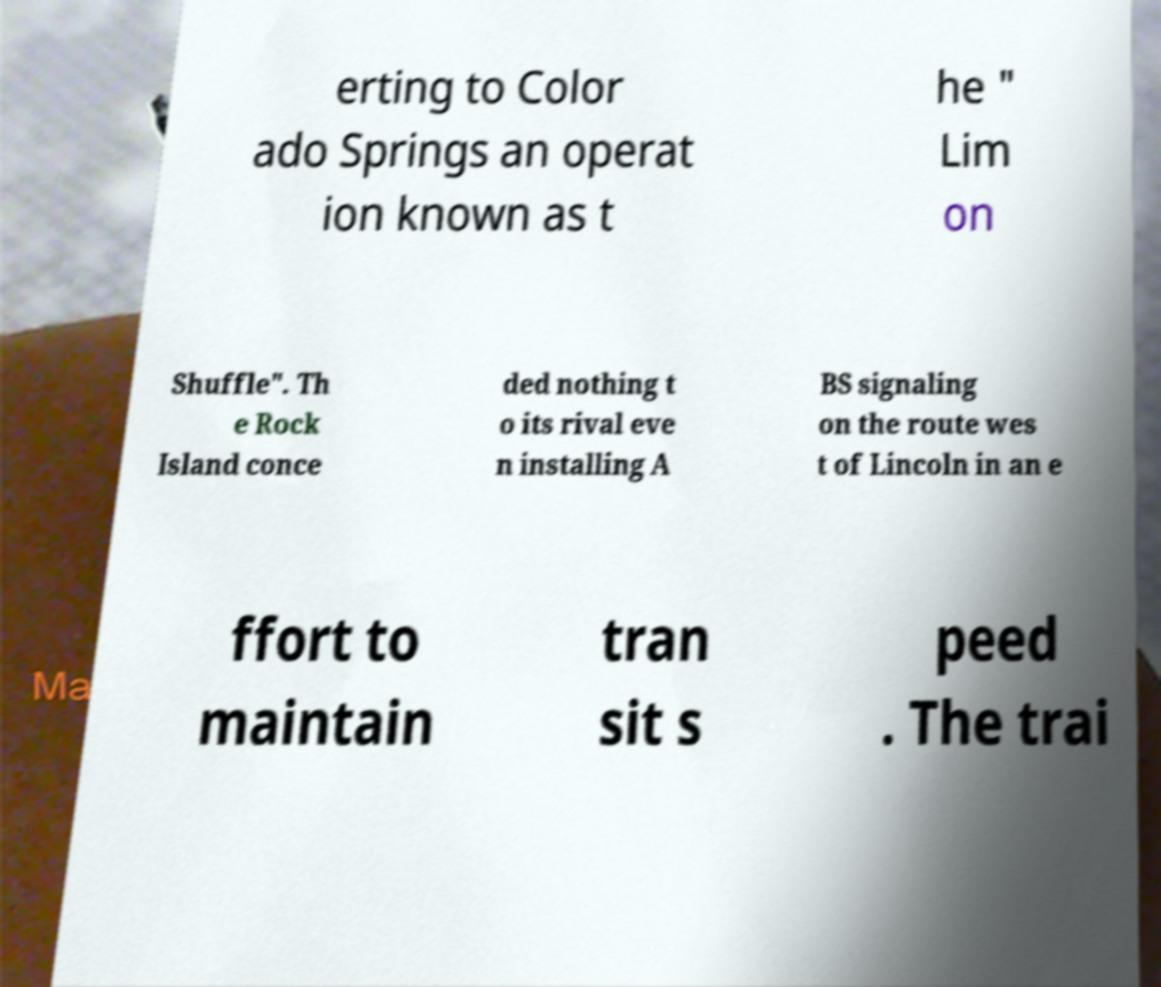Please identify and transcribe the text found in this image. erting to Color ado Springs an operat ion known as t he " Lim on Shuffle". Th e Rock Island conce ded nothing t o its rival eve n installing A BS signaling on the route wes t of Lincoln in an e ffort to maintain tran sit s peed . The trai 